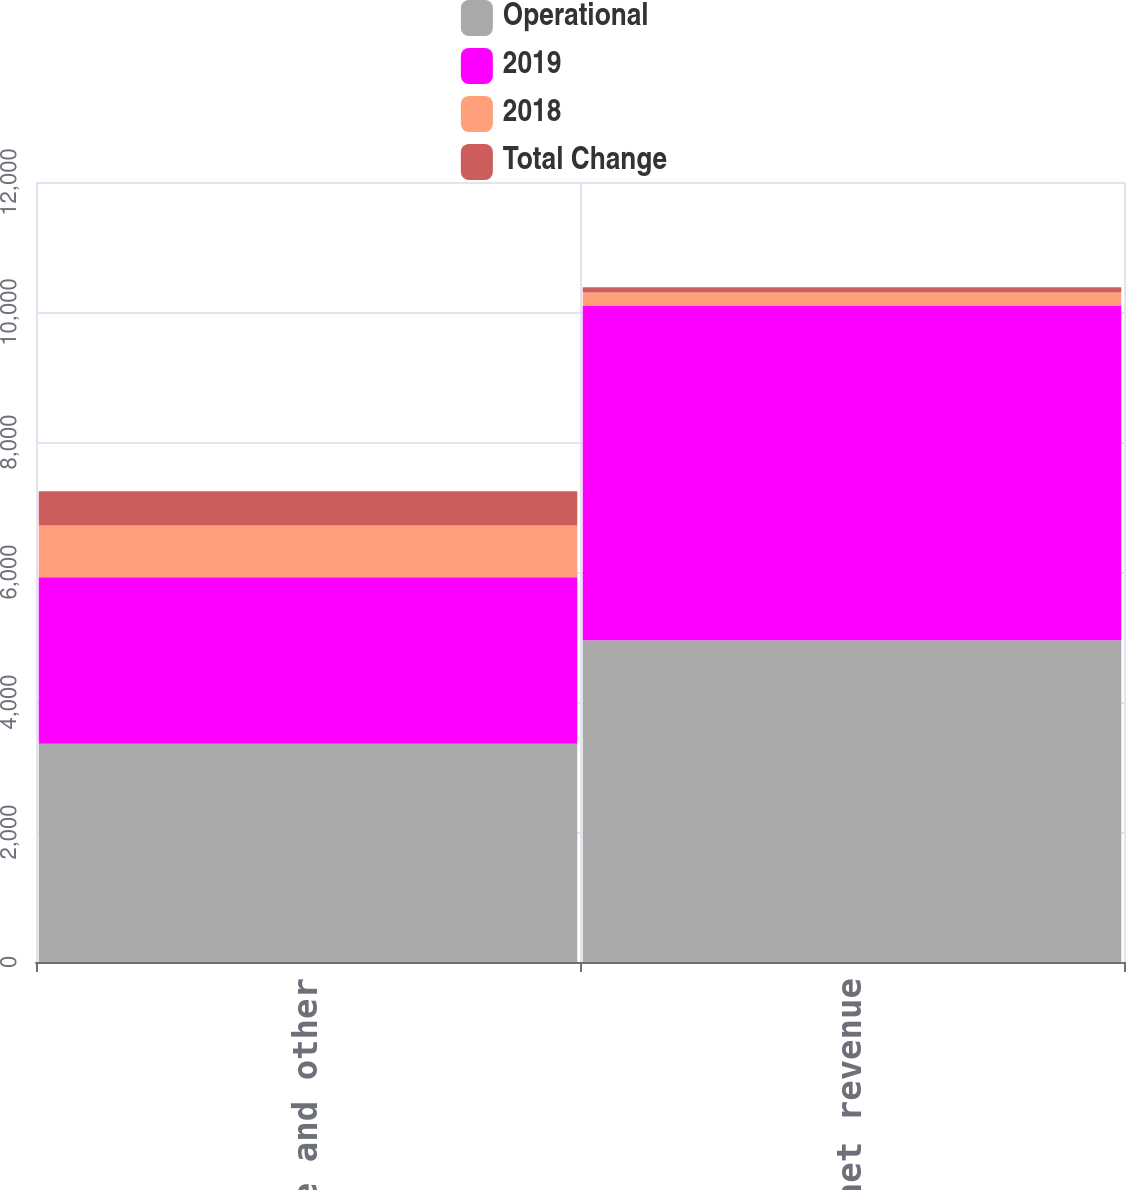Convert chart. <chart><loc_0><loc_0><loc_500><loc_500><stacked_bar_chart><ecel><fcel>Service and other<fcel>Total net revenue<nl><fcel>Operational<fcel>3357<fcel>4950<nl><fcel>2019<fcel>2564<fcel>5150<nl><fcel>2018<fcel>793<fcel>200<nl><fcel>Total Change<fcel>530<fcel>81<nl></chart> 